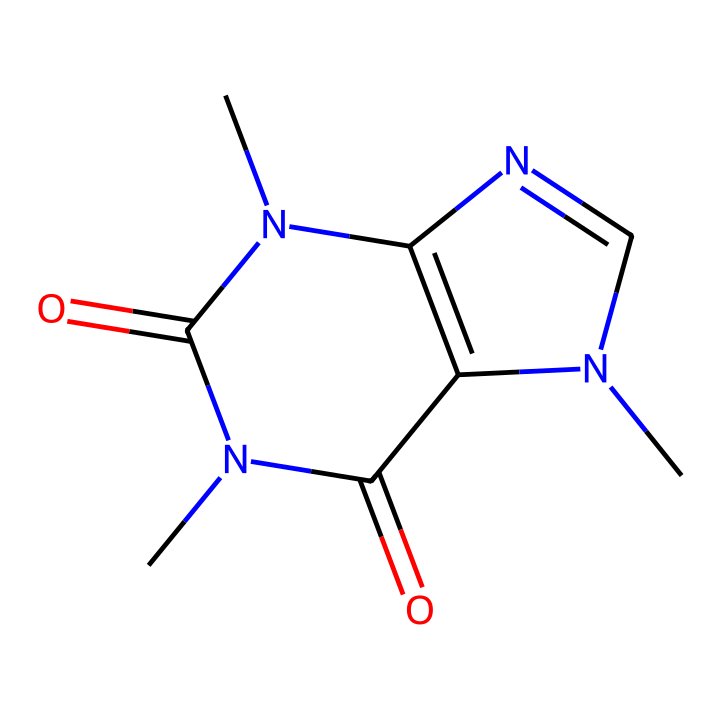how many carbon atoms are in the caffeine structure? By examining the SMILES representation, we can identify the carbon (C) symbols. There are a total of 8 carbon atoms present in the structure.
Answer: 8 what type of chemical is caffeine? Caffeine is classified as an alkaloid due to the presence of nitrogen atoms in its structure, which contributes to its physiological effects.
Answer: alkaloid how many nitrogen atoms are in caffeine? In the structure represented by the SMILES, there are 4 nitrogen (N) atoms clearly present.
Answer: 4 what does the presence of carbonyl groups indicate in this structure? The carbonyl groups (C=O) suggest that caffeine has keto functional groups, which influence its metabolic activity and solubility properties.
Answer: metabolic activity how many rings are present in the caffeine structure? The SMILES structure indicates two interconnected ring systems, which are characteristic of many alkaloids, including caffeine.
Answer: 2 what gives caffeine its stimulant properties? The nitrogen atoms in the heterocyclic ring are key, as they interact with neurotransmitter receptors in the brain, enhancing alertness and reducing fatigue.
Answer: nitrogen atoms 